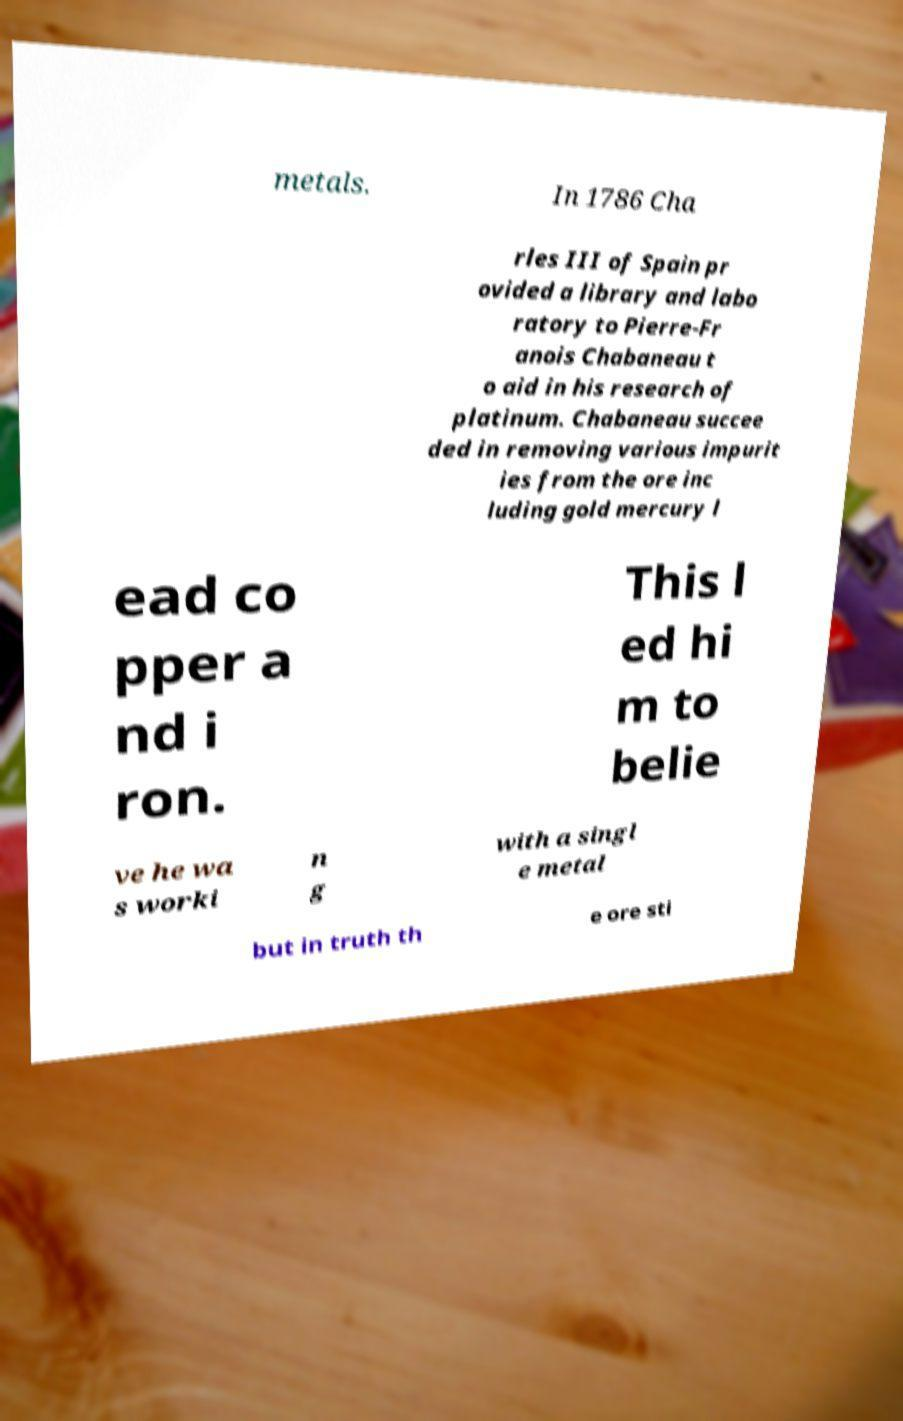Could you assist in decoding the text presented in this image and type it out clearly? metals. In 1786 Cha rles III of Spain pr ovided a library and labo ratory to Pierre-Fr anois Chabaneau t o aid in his research of platinum. Chabaneau succee ded in removing various impurit ies from the ore inc luding gold mercury l ead co pper a nd i ron. This l ed hi m to belie ve he wa s worki n g with a singl e metal but in truth th e ore sti 